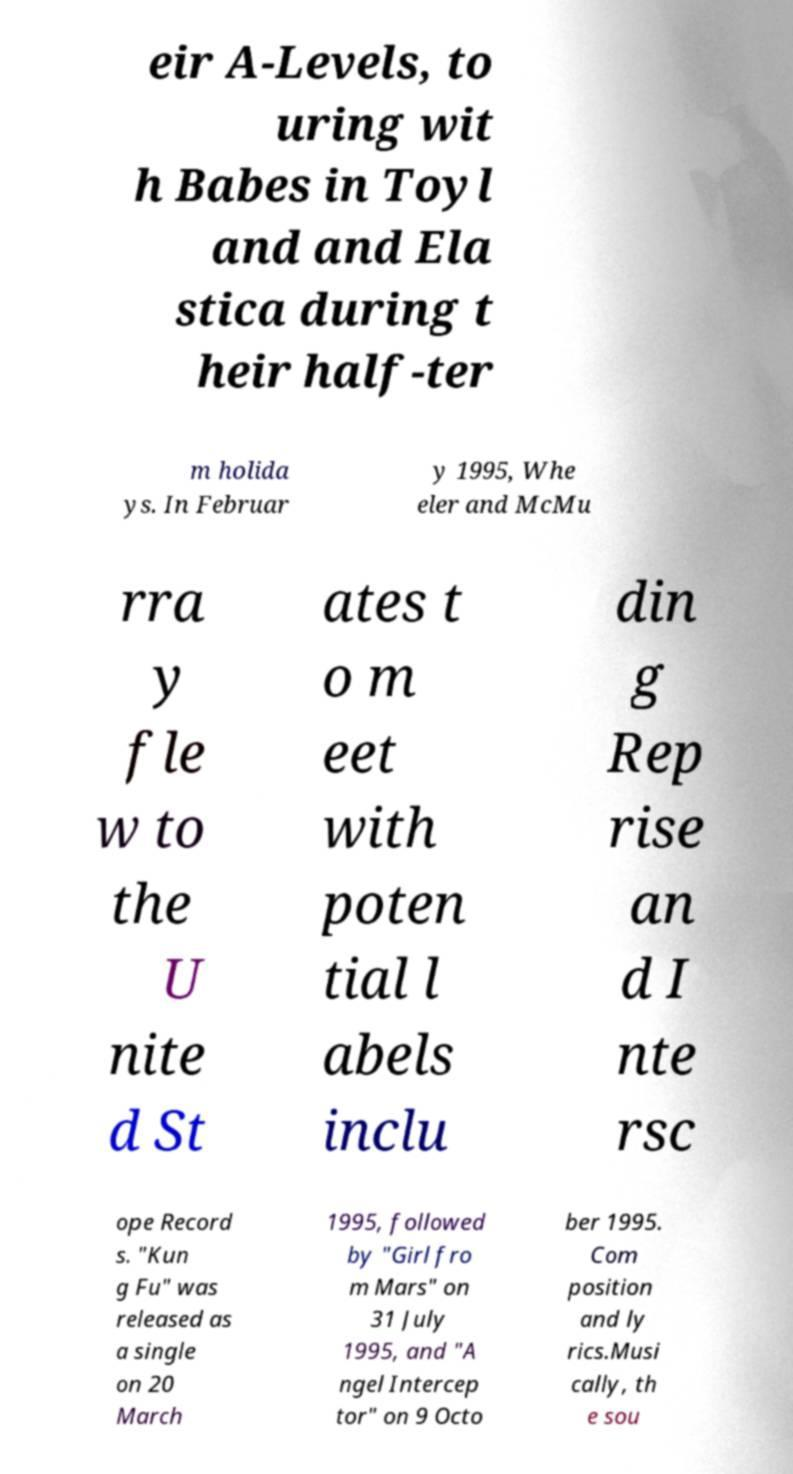Could you assist in decoding the text presented in this image and type it out clearly? eir A-Levels, to uring wit h Babes in Toyl and and Ela stica during t heir half-ter m holida ys. In Februar y 1995, Whe eler and McMu rra y fle w to the U nite d St ates t o m eet with poten tial l abels inclu din g Rep rise an d I nte rsc ope Record s. "Kun g Fu" was released as a single on 20 March 1995, followed by "Girl fro m Mars" on 31 July 1995, and "A ngel Intercep tor" on 9 Octo ber 1995. Com position and ly rics.Musi cally, th e sou 